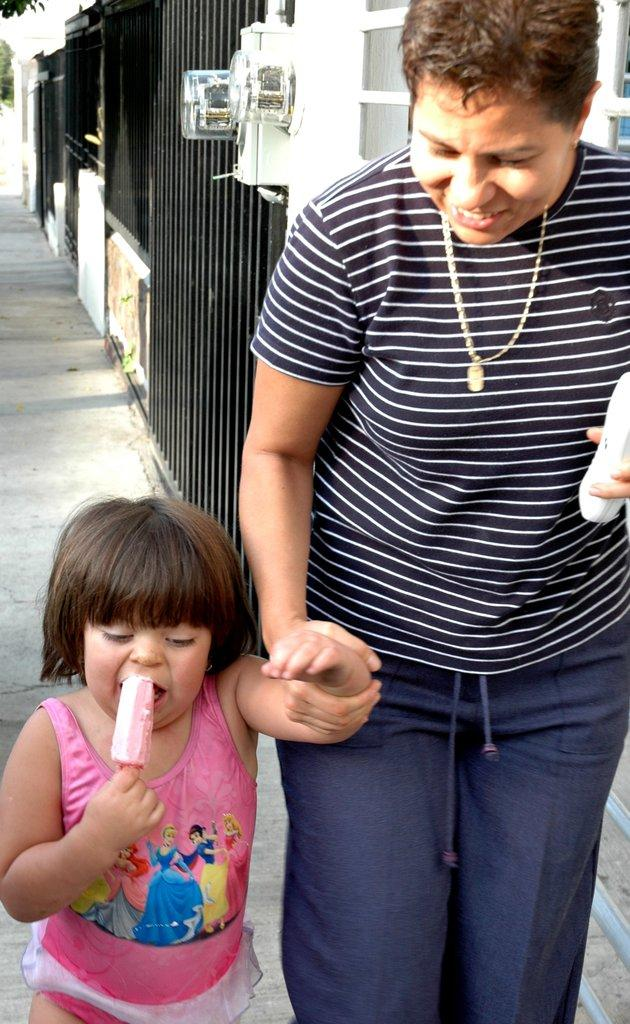Who is the main subject in the image? There is a woman in the image. What is the woman doing in the image? The woman is walking on a footpath and holding a kid. What is the kid doing in the image? The kid is eating an ice cream. What can be seen in the background of the image? There are grills and doors in the background of the image. What type of disgust can be seen on the woman's face in the image? There is no indication of disgust on the woman's face in the image. What color is the coat the woman is wearing in the image? The woman is not wearing a coat in the image, so we cannot determine its color. 